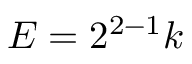Convert formula to latex. <formula><loc_0><loc_0><loc_500><loc_500>E = 2 ^ { 2 - 1 } k</formula> 